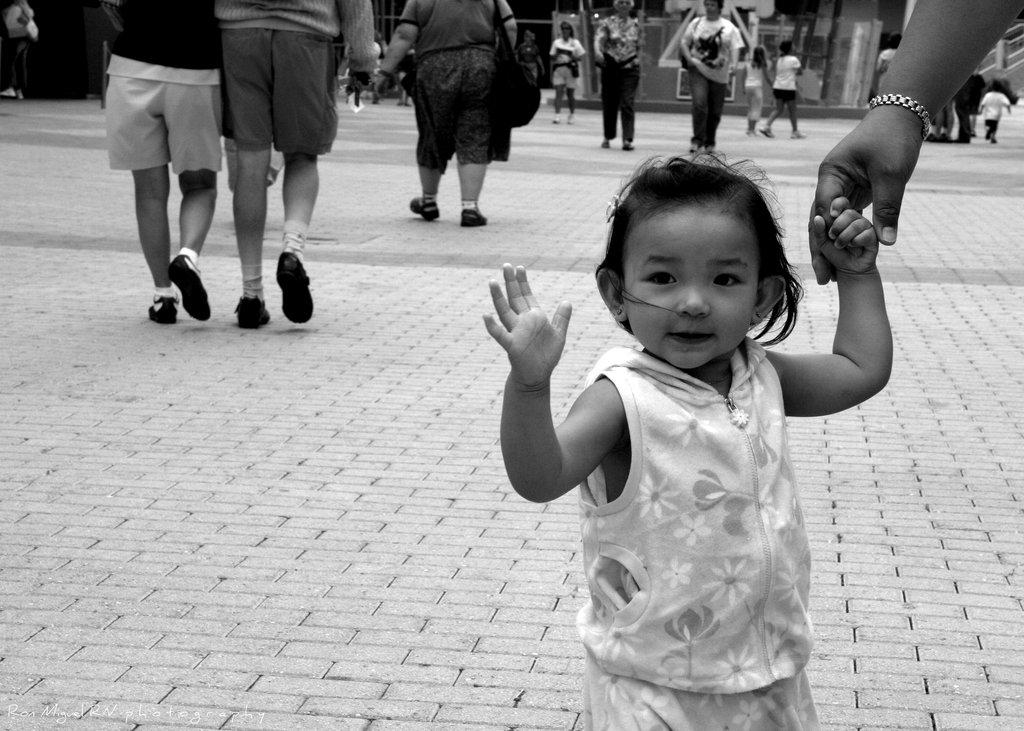Who is the kid holding hands with in the image? The kid is holding the hand of a person on the right side of the image. What is happening in the background of the image? There are people walking in the background. What is at the bottom of the image? There is a road at the bottom of the image. What is the effect of the summer heat on the people walking in the image? The image does not provide any information about the weather or season, so it cannot be determined if it is summer or if the heat is affecting the people walking. 